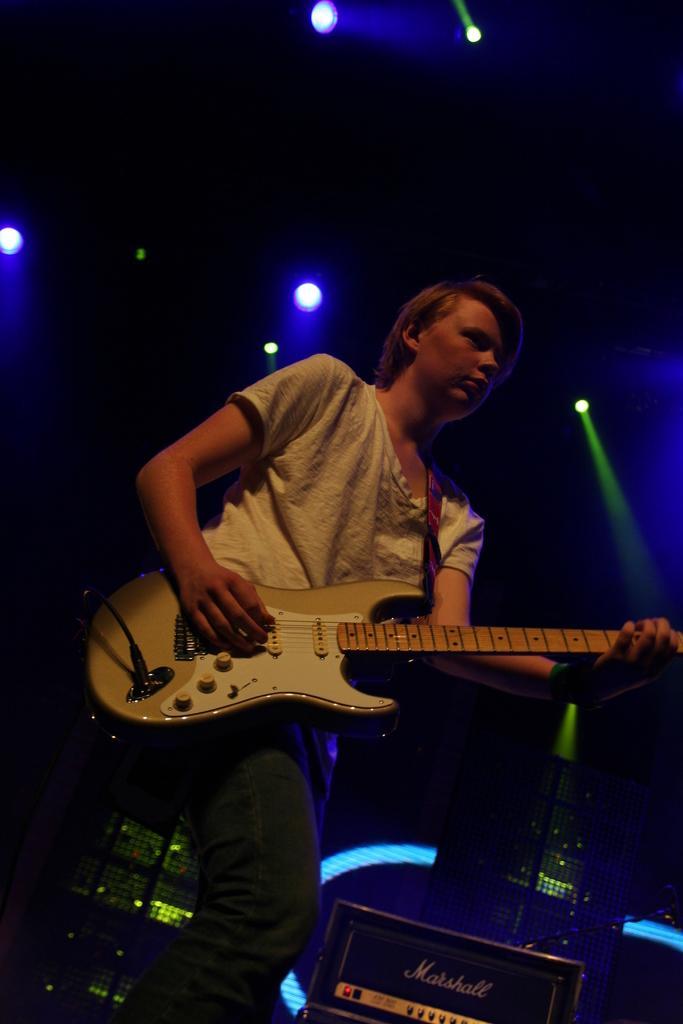Describe this image in one or two sentences. This is a picture of a person in white shirt holding a guitar and playing it and behind there are some speakers and above there are some lights to the roof. 